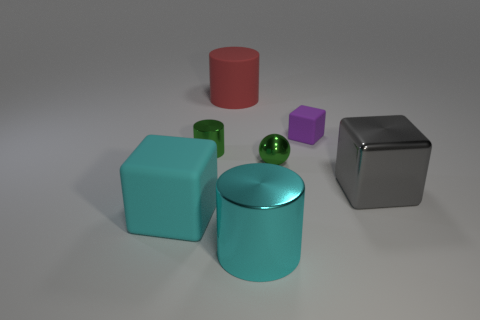Subtract all tiny green cylinders. How many cylinders are left? 2 Add 1 big cyan metallic cylinders. How many objects exist? 8 Subtract all green cylinders. How many cylinders are left? 2 Subtract all cylinders. How many objects are left? 4 Subtract 1 cylinders. How many cylinders are left? 2 Subtract all purple cubes. How many cyan balls are left? 0 Subtract all big cyan blocks. Subtract all large things. How many objects are left? 2 Add 6 tiny cubes. How many tiny cubes are left? 7 Add 3 blue cylinders. How many blue cylinders exist? 3 Subtract 0 blue spheres. How many objects are left? 7 